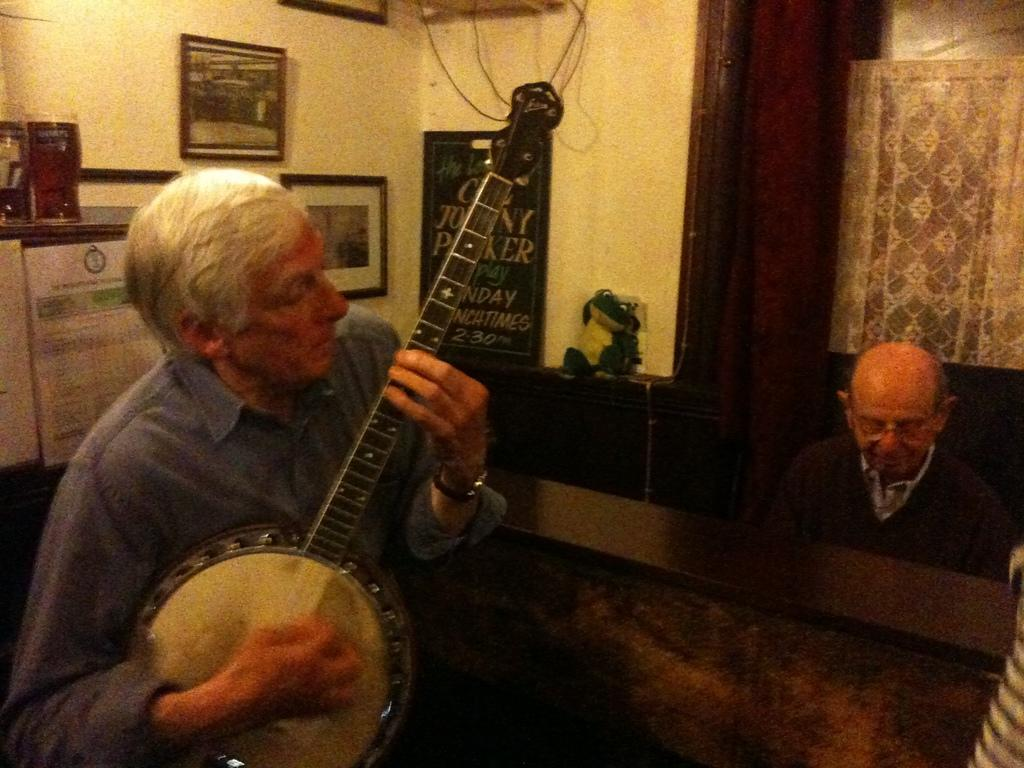How many people are in the image? There are two people in the image. What is one person doing in the image? One person is holding a guitar. What is the other person doing in the image? The other person is sitting. What can be seen in the background of the image? There is a wall, photo frames, a calendar, and a board in the background of the image. What type of chicken is visible in the image? There is no chicken present in the image. How does the rake help the person sitting in the image? There is no rake present in the image, so it cannot help the person sitting. 